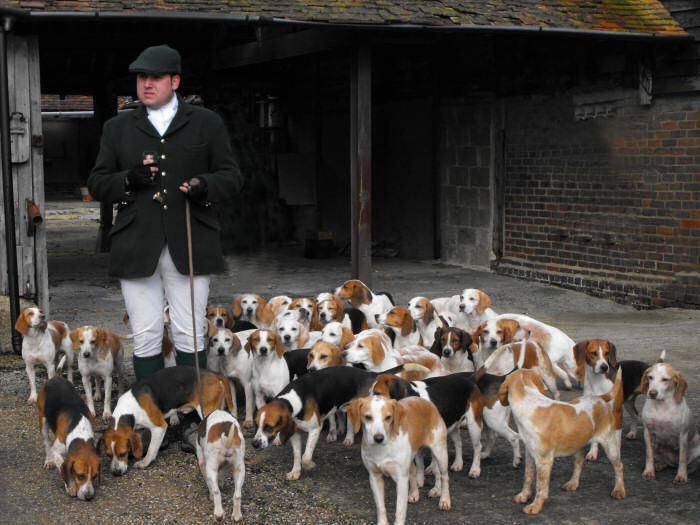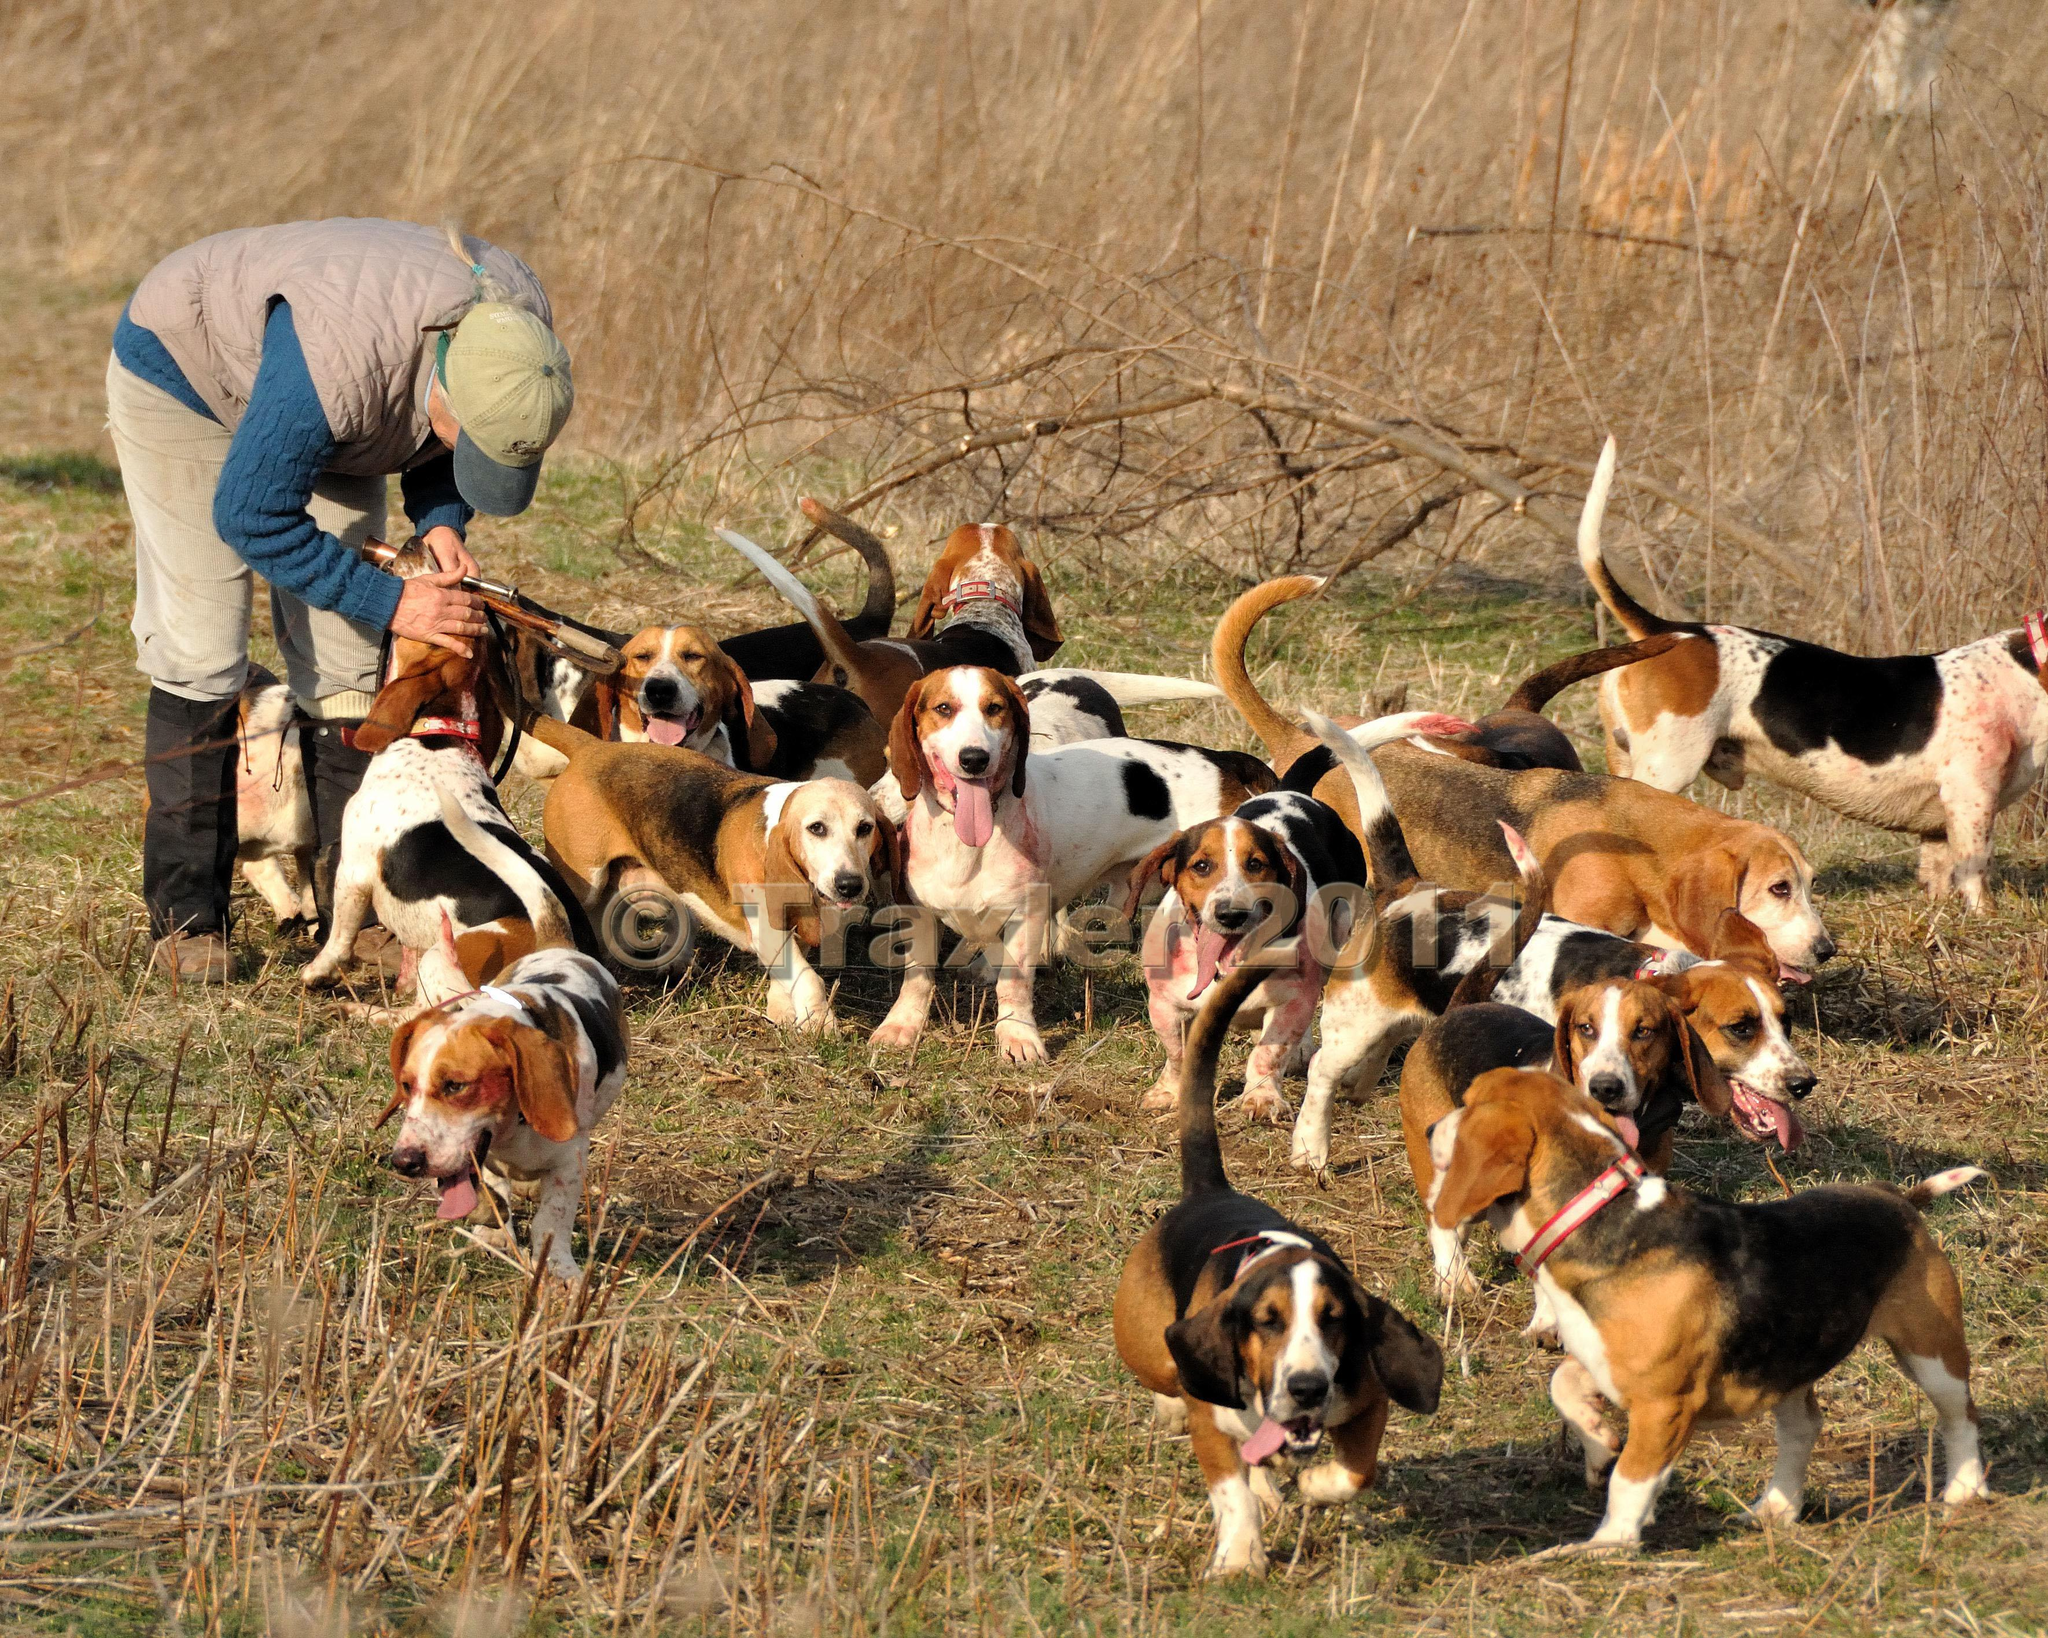The first image is the image on the left, the second image is the image on the right. Considering the images on both sides, is "A man is standing with the dogs in the image on the left." valid? Answer yes or no. Yes. The first image is the image on the left, the second image is the image on the right. Evaluate the accuracy of this statement regarding the images: "A man in a cap and blazer stands holding a whip-shaped item, with a pack of beagles around him.". Is it true? Answer yes or no. Yes. 